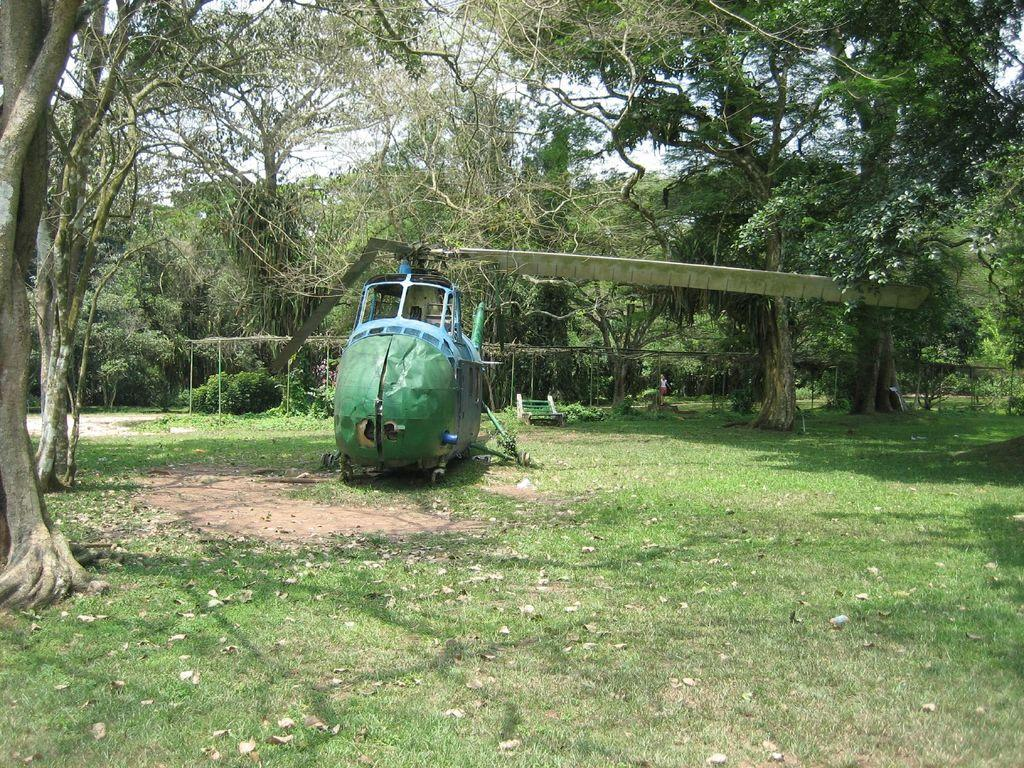What is the main subject of the picture? The main subject of the picture is a helicopter. What other objects or features can be seen in the picture? There is a bench, plants, grass, and trees visible in the picture. What can be seen in the background of the picture? The sky is visible in the background of the picture. Can you tell me how many monkeys are sitting on the helicopter in the image? There are no monkeys present in the image; it features a helicopter, a bench, plants, grass, trees, and the sky. What type of leather material is used for the seats in the helicopter? There is no information about the seats or any leather material in the image. 